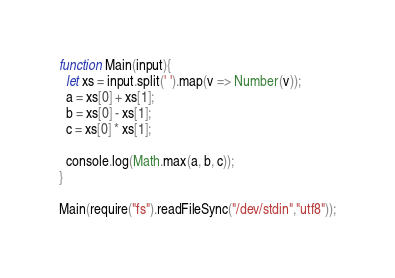<code> <loc_0><loc_0><loc_500><loc_500><_JavaScript_>function Main(input){
  let xs = input.split(' ').map(v => Number(v));
  a = xs[0] + xs[1];
  b = xs[0] - xs[1];
  c = xs[0] * xs[1];

  console.log(Math.max(a, b, c));
}

Main(require("fs").readFileSync("/dev/stdin","utf8"));</code> 